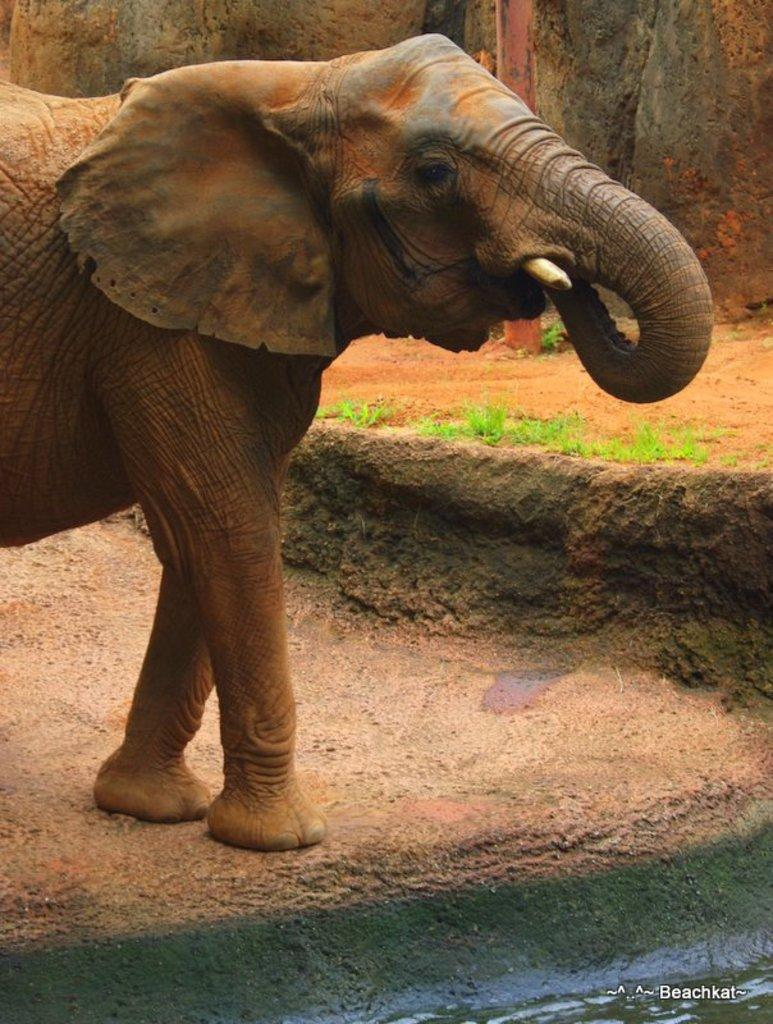What animal is present in the picture? There is an elephant in the picture. What is the position of the elephant in the image? The elephant is standing. What type of environment is depicted in the picture? There is water and grass in the picture, suggesting a natural setting. Is there any additional information or marking on the image? Yes, there is a watermark on the image. What type of flower is being played by the elephant in the image? There is no flower or musical instrument present in the image, and the elephant is not playing anything. 